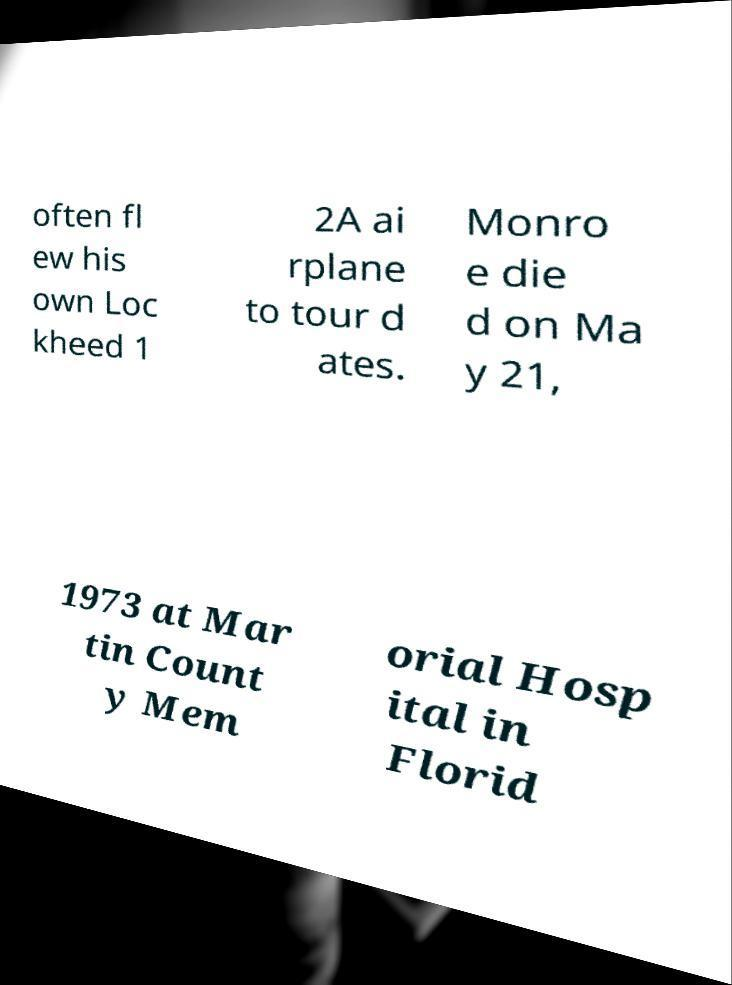What messages or text are displayed in this image? I need them in a readable, typed format. often fl ew his own Loc kheed 1 2A ai rplane to tour d ates. Monro e die d on Ma y 21, 1973 at Mar tin Count y Mem orial Hosp ital in Florid 